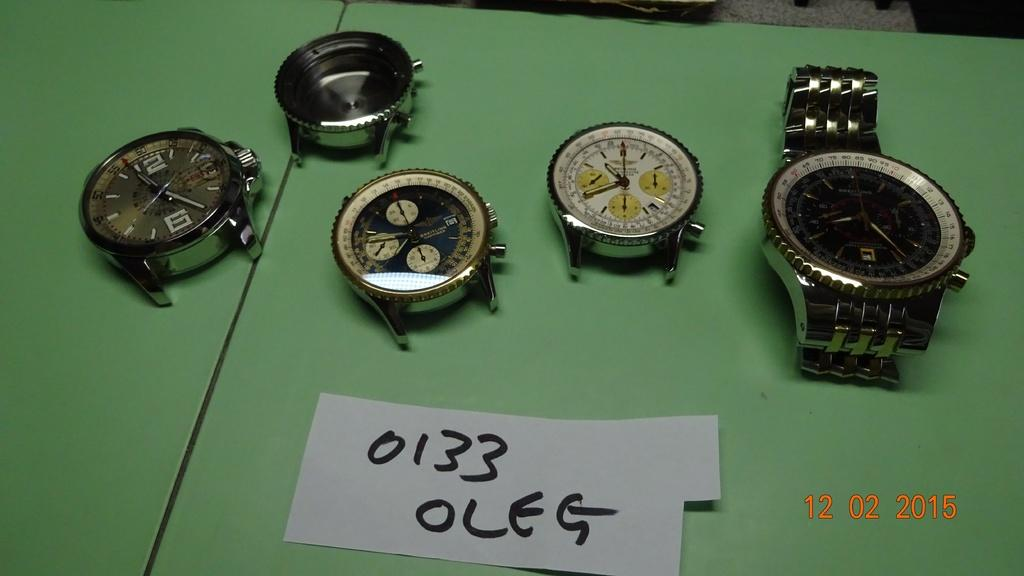<image>
Describe the image concisely. Several watches lay on a green surface, in front of them is a piece of paper that reads "0133 OLEG". 